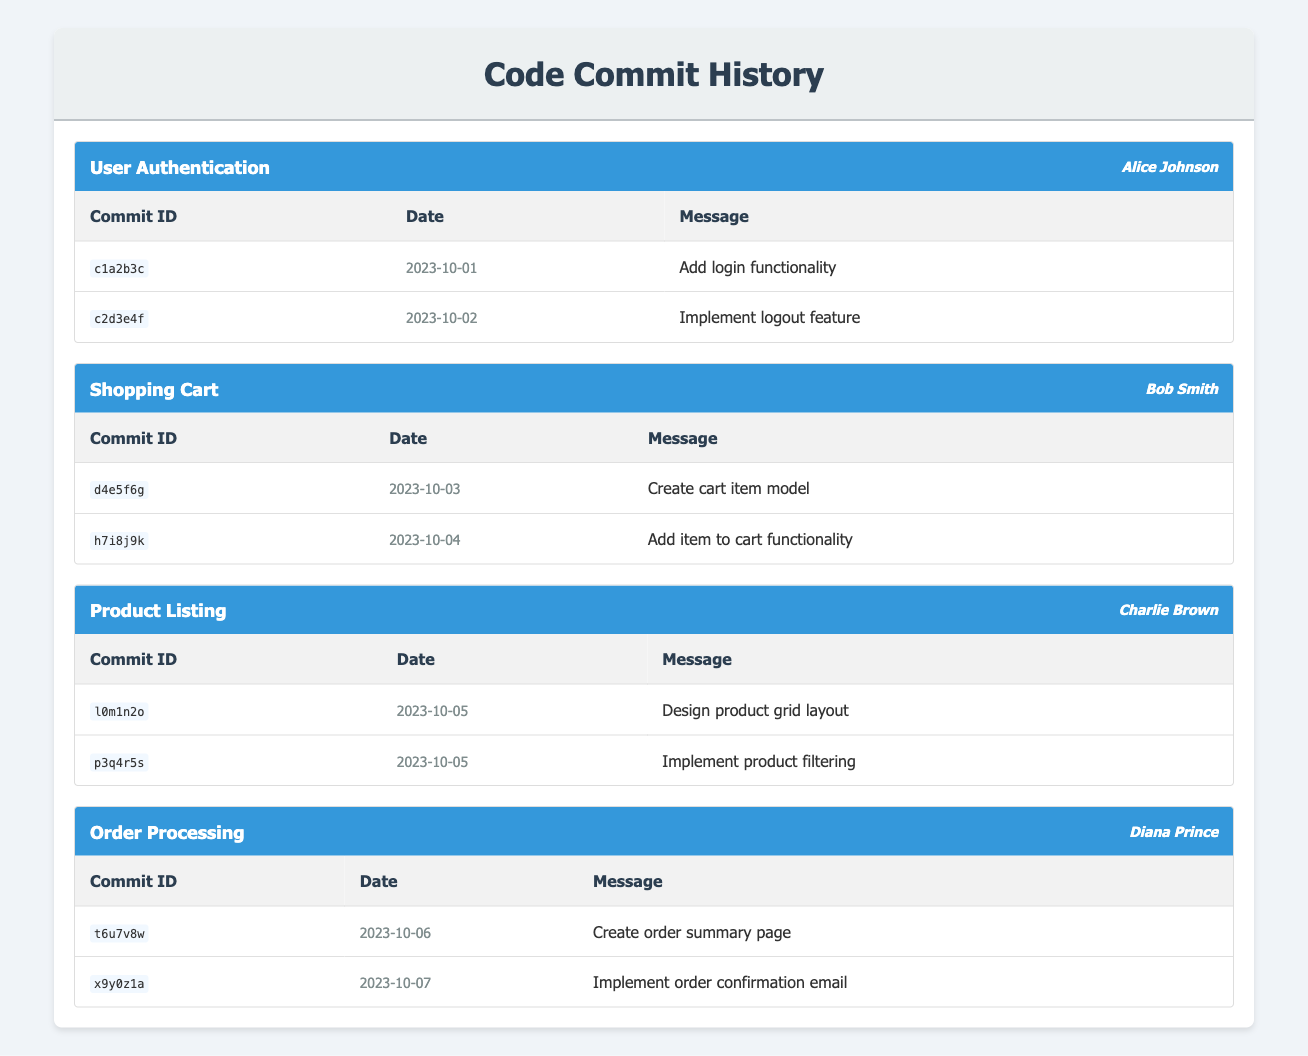What features were developed by Alice Johnson? Alice Johnson worked on the user-authentication feature branch, which includes two commits: "Add login functionality" and "Implement logout feature."
Answer: User authentication How many commits did Bob Smith make? Bob Smith has a total of 2 commits listed under the shopping-cart feature branch: "Create cart item model" and "Add item to cart functionality."
Answer: 2 Was there a commit made on October 05? Yes, both commits under the product-listing feature branch were made on October 05 on the same day.
Answer: Yes Who has more commits, Charlie Brown or Diana Prince? Charlie Brown has 2 commits under the product-listing feature, while Diana Prince also has 2 commits under the order-processing feature, making their commit counts equal.
Answer: They have the same number of commits What is the total number of commits across all feature branches? Counting each commit, we have 2 commits for user-authentication, 2 for shopping-cart, 2 for product-listing, and 2 for order-processing, which adds up to 8.
Answer: 8 What was the message of the first commit in the order-processing branch? The first commit listed under the order-processing branch is "Create order summary page" by Diana Prince, which corresponds to commit ID t6u7v8w.
Answer: Create order summary page How many commits did Alice Johnson and Bob Smith make combined? Alice Johnson made 2 commits and Bob Smith made 2 commits. Combining them gives a total of 4 commits (2 + 2 = 4).
Answer: 4 Is there a commit confirming the implementation of product filtering? Yes, there is a commit under the product-listing feature by Charlie Brown with the message "Implement product filtering," confirming this implementation.
Answer: Yes Which feature branch had commits on consecutive days? The feature branches user-authentication, shopping-cart, product-listing, and order-processing all have commits made on consecutive days; however, since October 5 has two commits on the same day under product-listing, it's notable.
Answer: Product-listing 